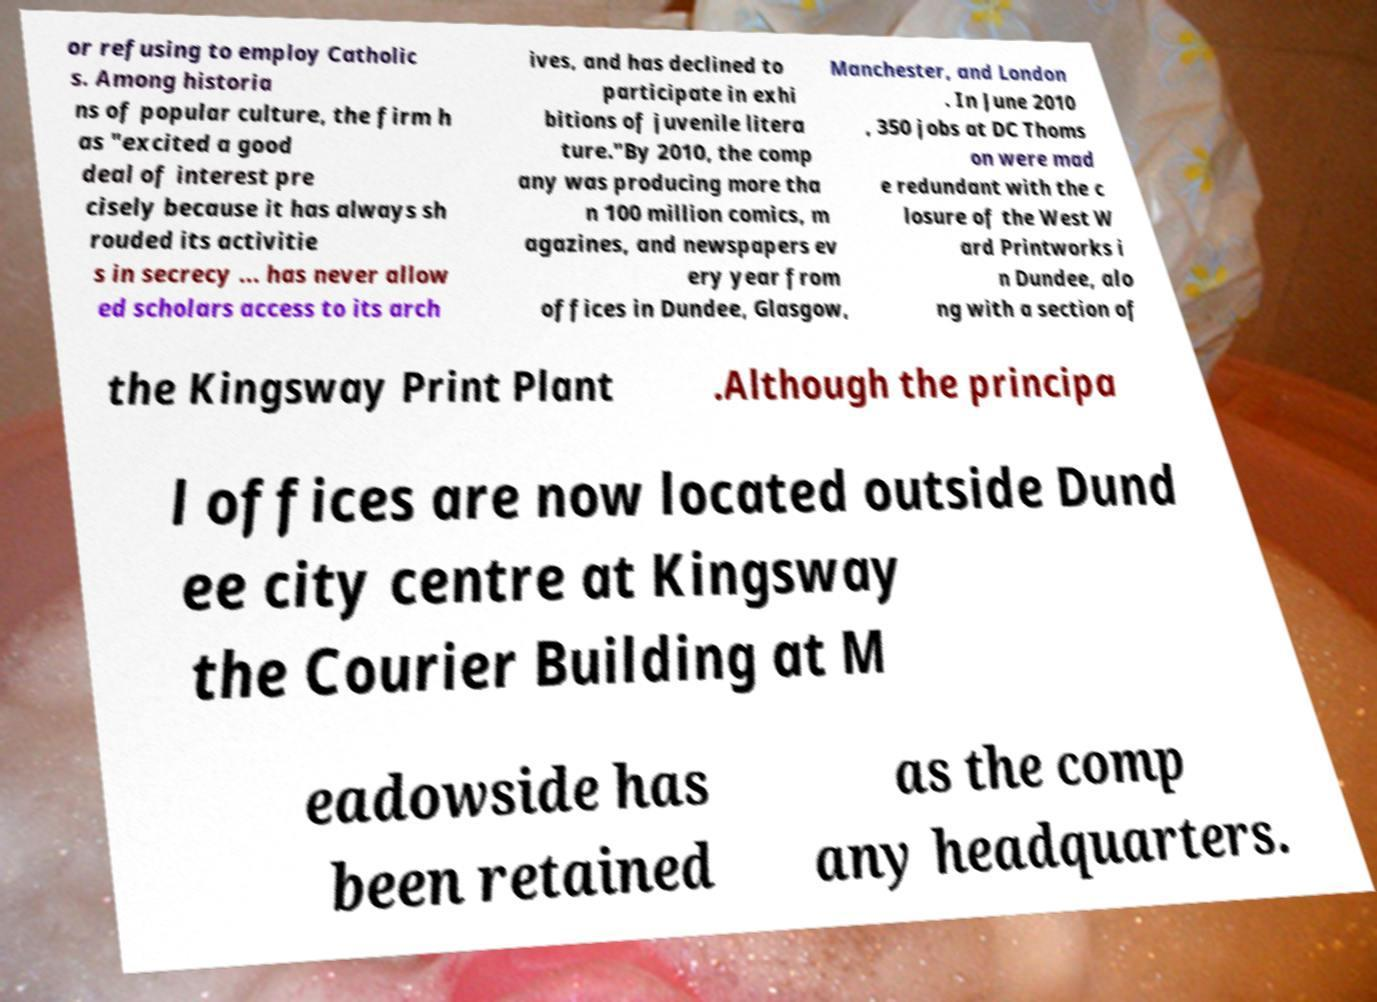Can you read and provide the text displayed in the image?This photo seems to have some interesting text. Can you extract and type it out for me? or refusing to employ Catholic s. Among historia ns of popular culture, the firm h as "excited a good deal of interest pre cisely because it has always sh rouded its activitie s in secrecy ... has never allow ed scholars access to its arch ives, and has declined to participate in exhi bitions of juvenile litera ture."By 2010, the comp any was producing more tha n 100 million comics, m agazines, and newspapers ev ery year from offices in Dundee, Glasgow, Manchester, and London . In June 2010 , 350 jobs at DC Thoms on were mad e redundant with the c losure of the West W ard Printworks i n Dundee, alo ng with a section of the Kingsway Print Plant .Although the principa l offices are now located outside Dund ee city centre at Kingsway the Courier Building at M eadowside has been retained as the comp any headquarters. 